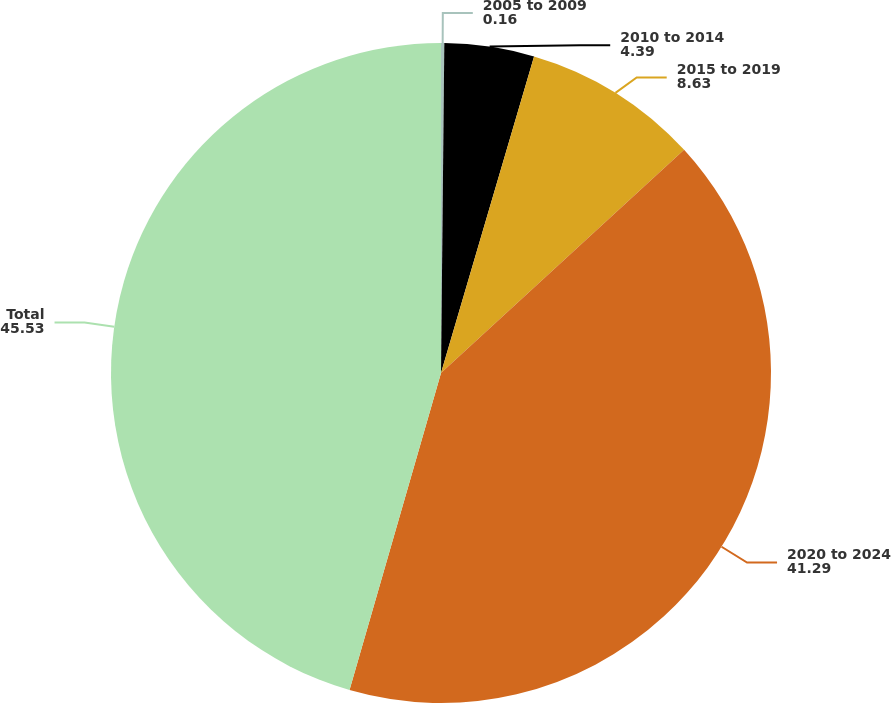Convert chart to OTSL. <chart><loc_0><loc_0><loc_500><loc_500><pie_chart><fcel>2005 to 2009<fcel>2010 to 2014<fcel>2015 to 2019<fcel>2020 to 2024<fcel>Total<nl><fcel>0.16%<fcel>4.39%<fcel>8.63%<fcel>41.29%<fcel>45.53%<nl></chart> 